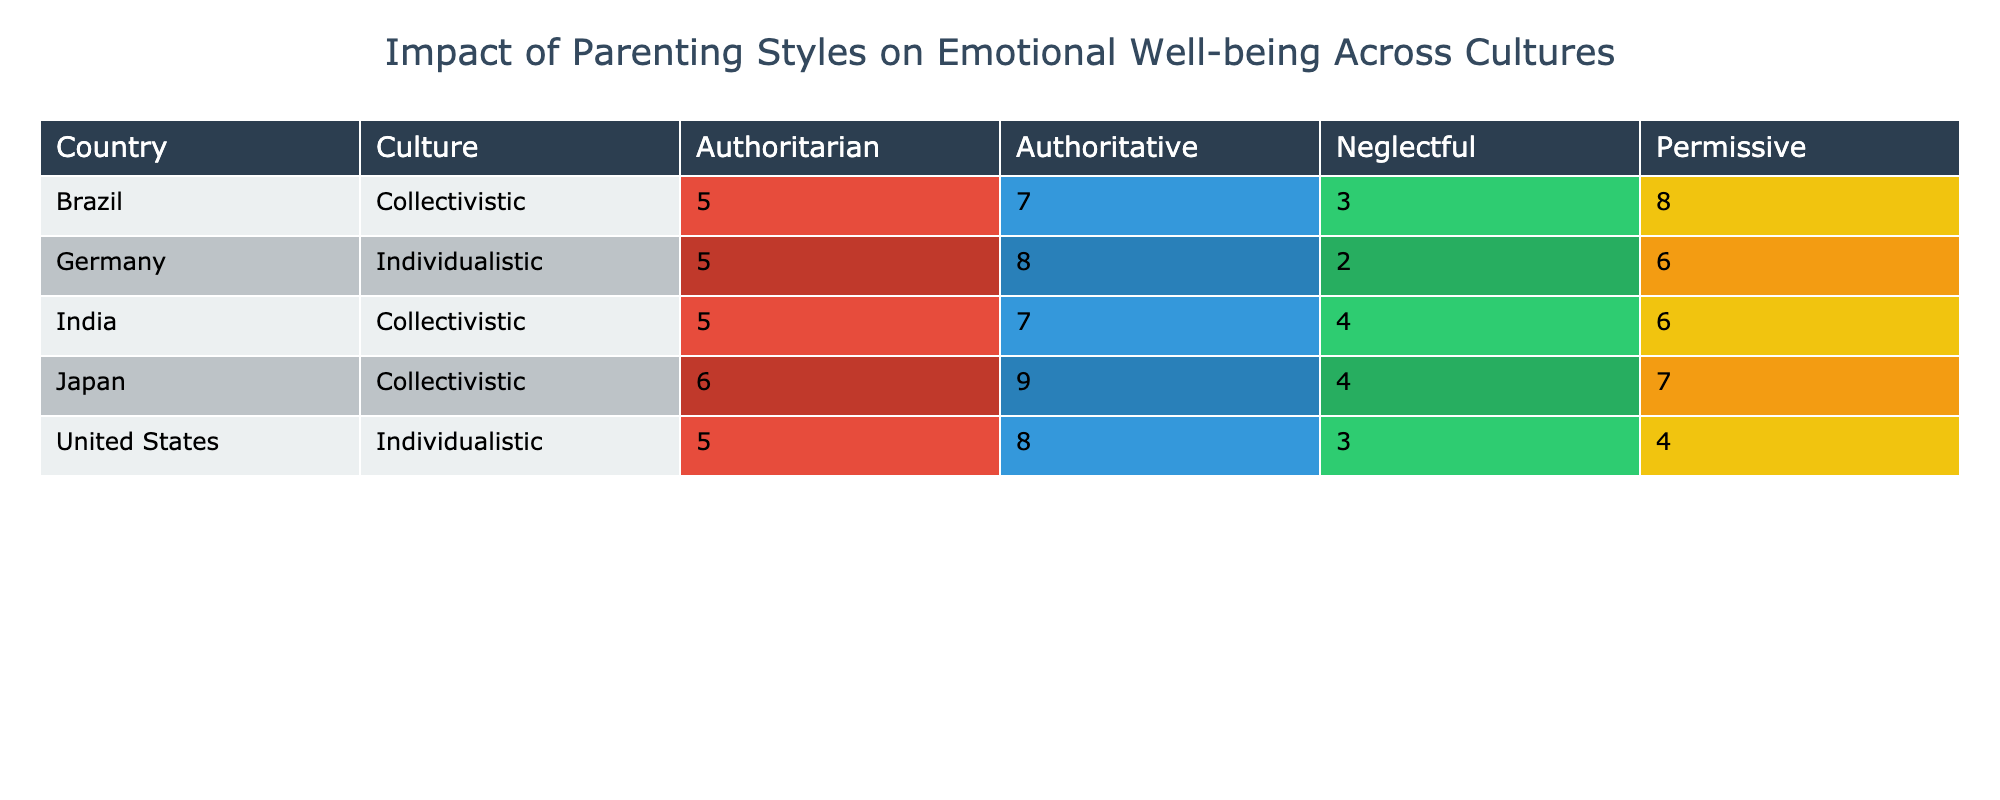What is the Emotional Well-being Score for Authoritative parenting style in the United States? In the table, I look under the "United States" row and the "Authoritative" column. The score listed there is 8.
Answer: 8 What country shows the highest Emotional Well-being Score with the Permissive parenting style? The countries and their corresponding scores for the Permissive parenting style need to be compared. The scores are: United States (4), Japan (7), Germany (6), India (6), and Brazil (8). Brazil has the highest score of 8.
Answer: 8 What is the average Emotional Well-being Score for Authoritarian parenting style across all cultures? I sum the scores for Authoritarian parenting style across all countries. They are: 5 (US), 6 (Japan), 5 (Germany), 5 (India), and 5 (Brazil). The total score is 5 + 6 + 5 + 5 + 5 = 26. There are 5 entries, so the average is 26/5 = 5.2.
Answer: 5.2 Is the Emotional Well-being Score for Neglectful parenting in Germany higher than in the United States? For Germany, the Neglectful score is 2. For the United States, the score is 3. Since 3 is greater than 2, the score for the United States is higher.
Answer: No Which parenting style produces the highest Emotional Well-being Score in Japan? I look at the scores for Japan: Authoritative (9), Authoritarian (6), Permissive (7), and Neglectful (4). The highest score is from the Authoritative style, which is 9.
Answer: 9 Which culture has the lowest Emotional Well-being Score when Neglectful parenting is practiced? I compare the scores for Neglectful parenting across all cultures. The scores are: US (3), Japan (4), Germany (2), India (4), and Brazil (3). The lowest score is 2 from Germany.
Answer: Germany In terms of Emotional Well-being Scores, which culture shows the least variation in scores among the different parenting styles? To determine this, I analyze the scores for each culture. The standard deviation is lowest for the United States (3, 4, 5, 8 = 3) compared to Japan (4, 6, 7, 9 = 2) and others, indicating less variation.
Answer: Japan What is the difference in Emotional Well-being Scores between Authoritative and Neglectful parenting styles in India? The Authoritative score in India is 7 and the Neglectful score is 4. The difference is 7 - 4 = 3.
Answer: 3 